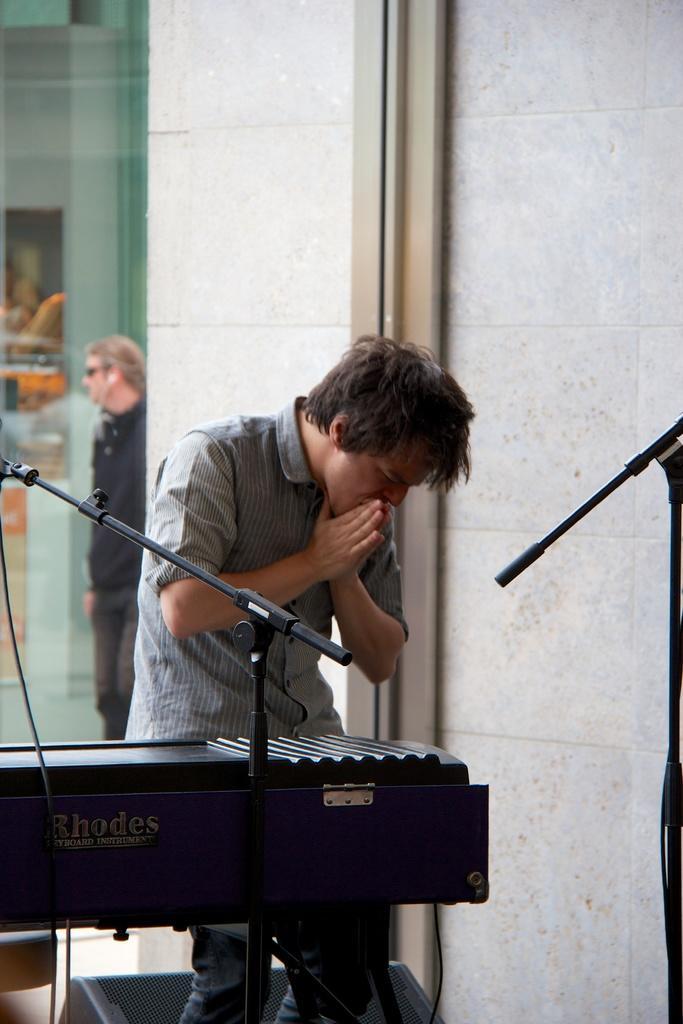Could you give a brief overview of what you see in this image? There is a man standing in front there is a musical instrument,at the back side there is a glass window. 